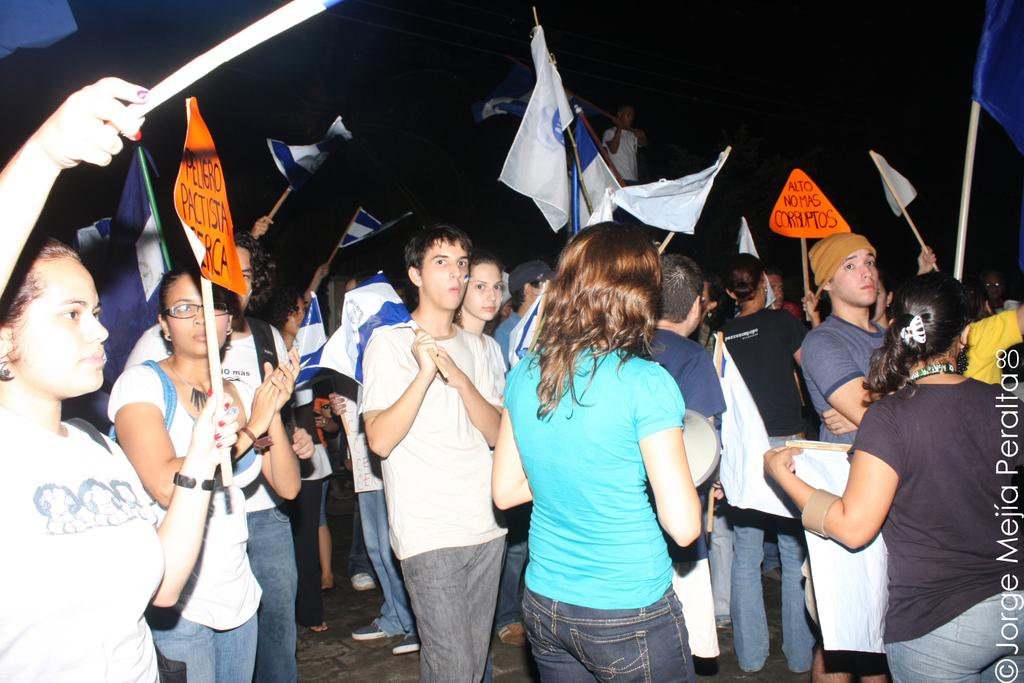How many people are present in the image? There are many people in the image. What are some people holding in their hands? Some people are holding flags in their hands. What else might people be holding in their hands? Some people are holding objects in their hands. What type of lamp can be seen in the image? There is no lamp present in the image. What is the taste of the bedroom in the image? There is no bedroom present in the image, and therefore no taste can be associated with it. 